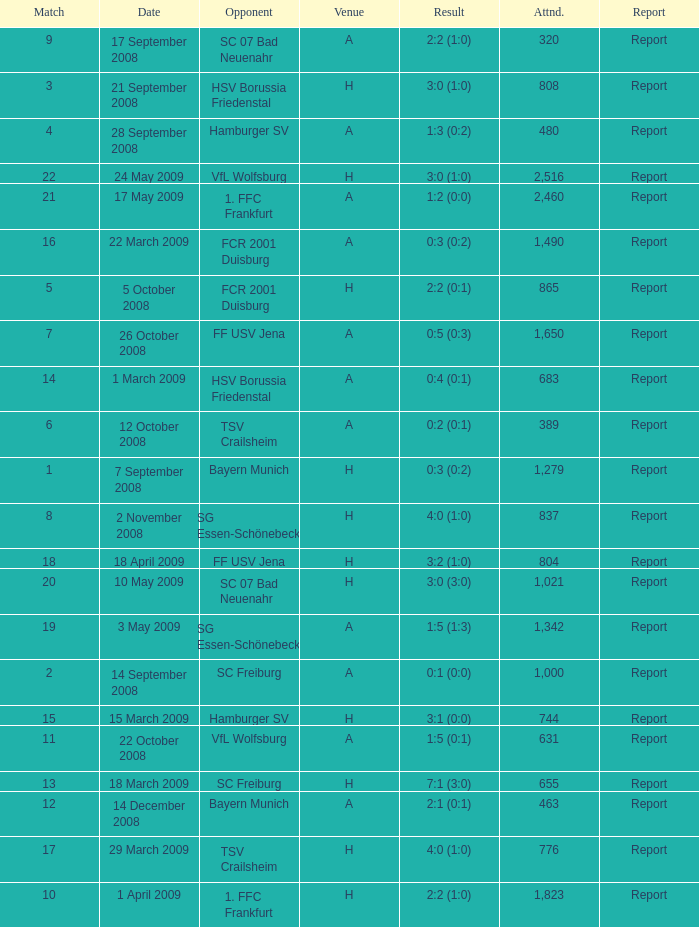What is the match number that had a result of 0:5 (0:3)? 1.0. 